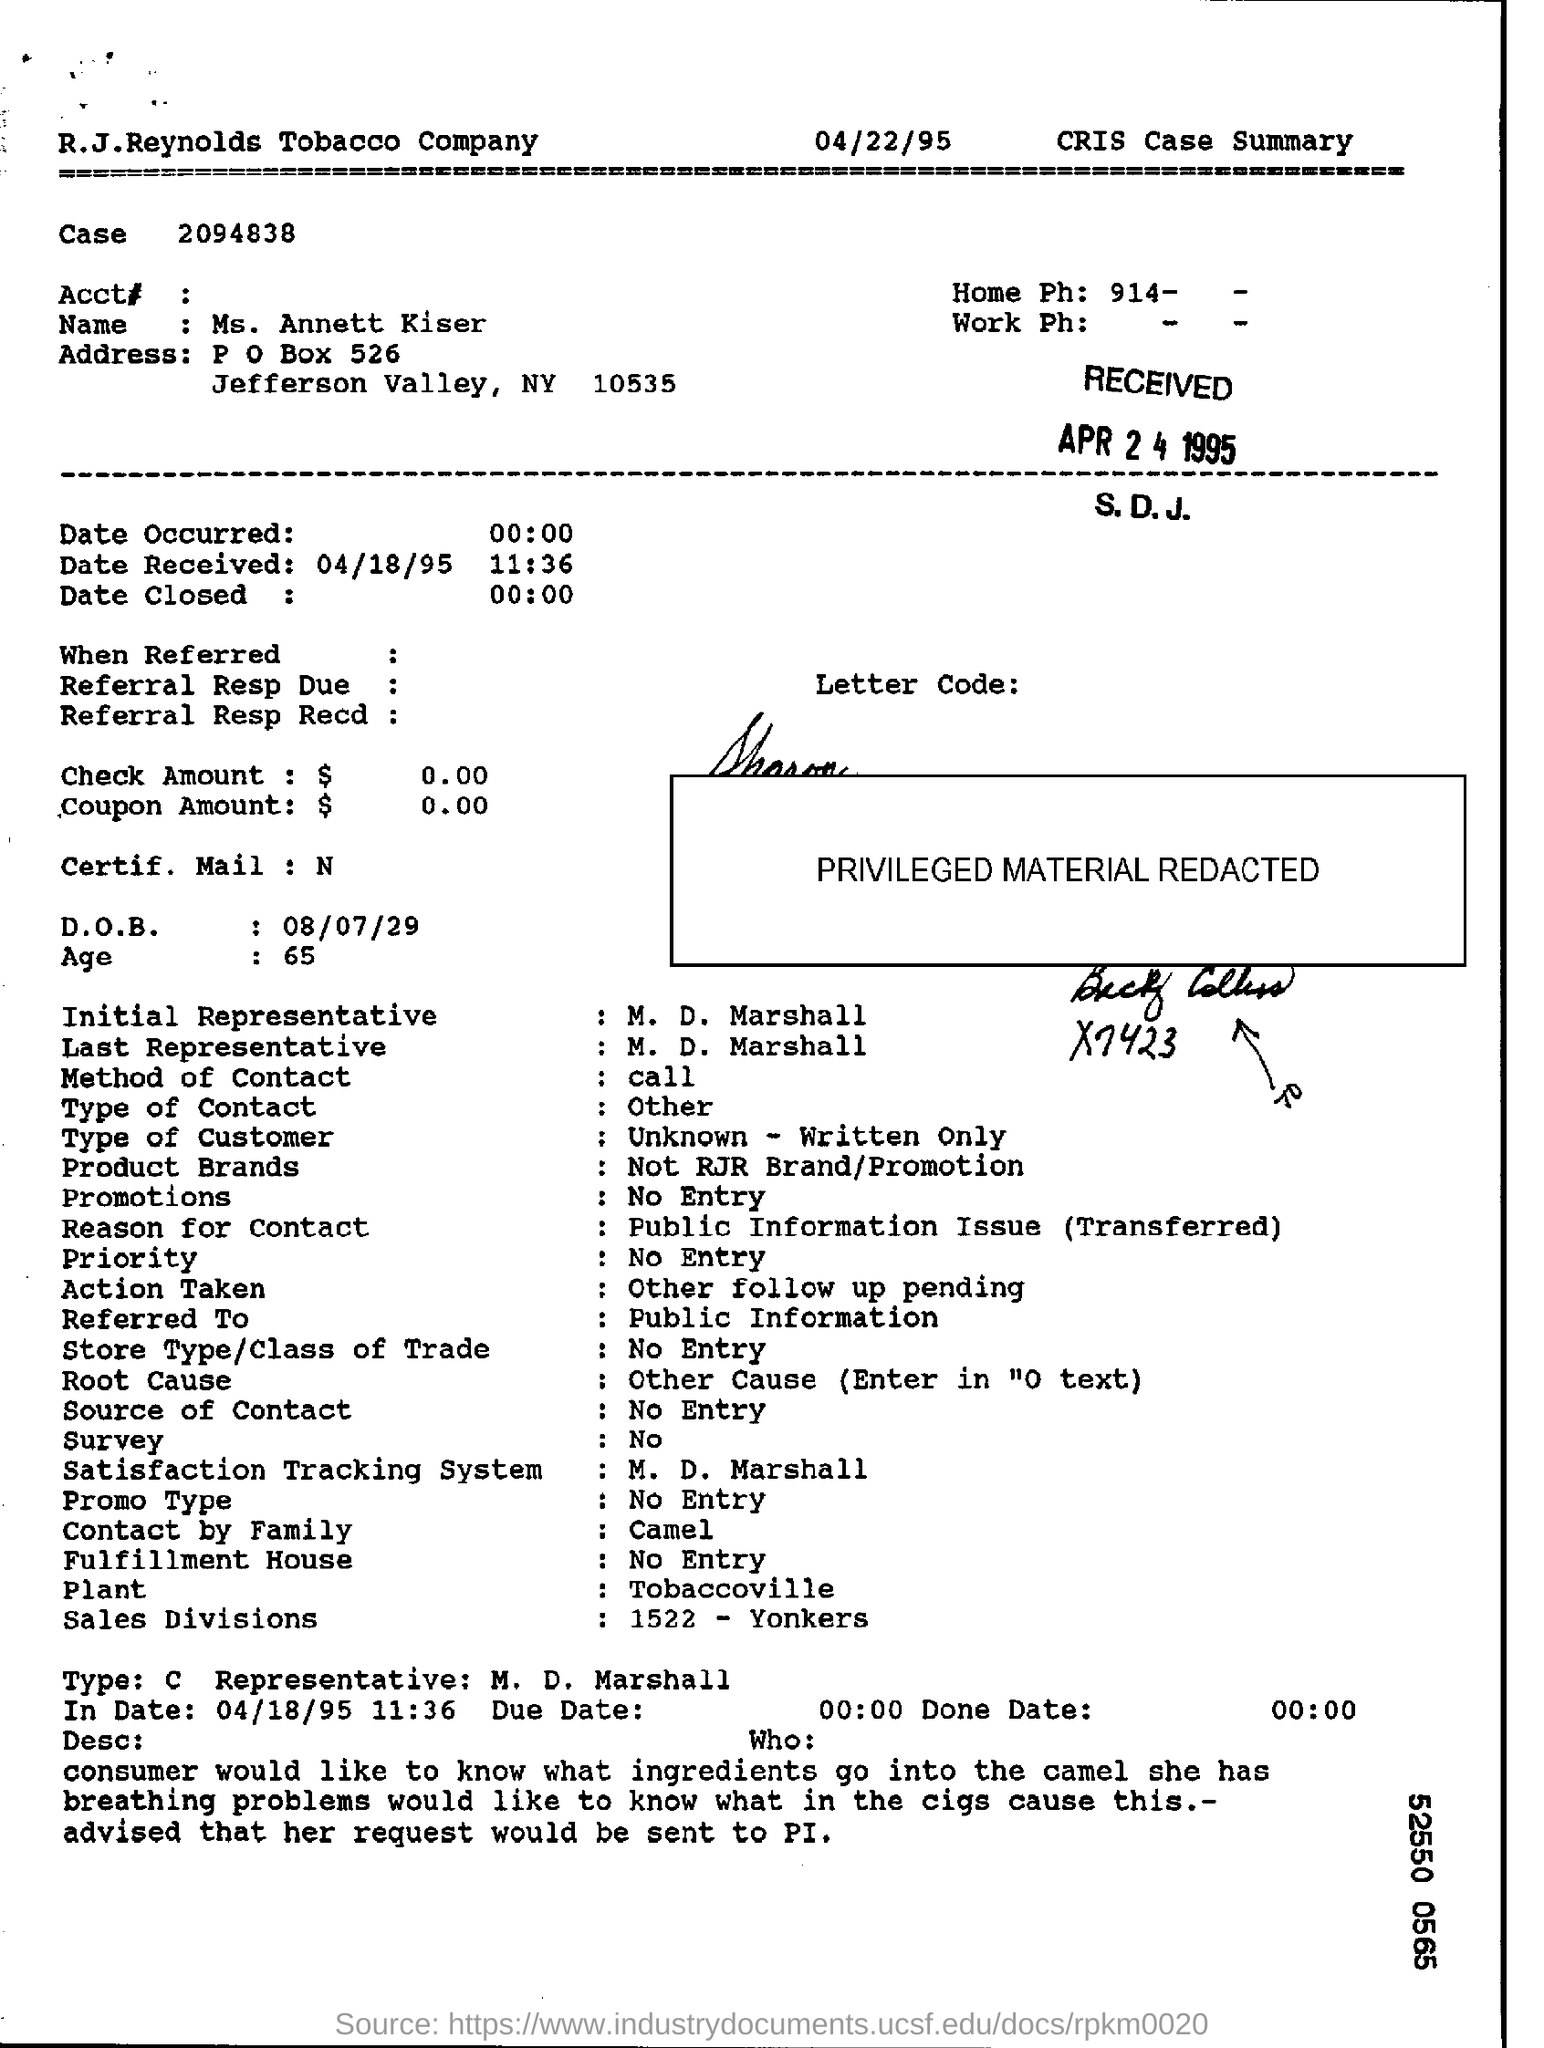What is the name of person in the cris case summary ?
Your answer should be very brief. Ms. Annett Kiser. What is the d.o.b. in the cris case summary?
Your answer should be compact. 08/07/29. 